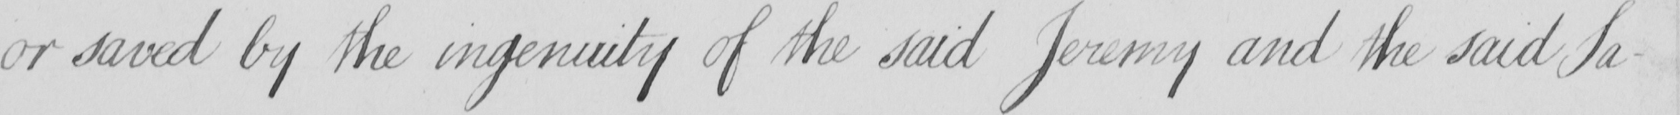Can you tell me what this handwritten text says? or saved by the ingenuity of the said Jeremy and the said Sa- 